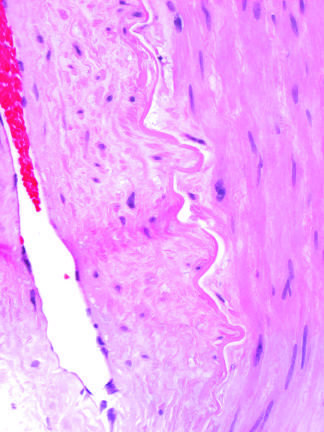what is vascular changes and fibrosis of salivary glands produced by?
Answer the question using a single word or phrase. Radiation therapy of the neck region 